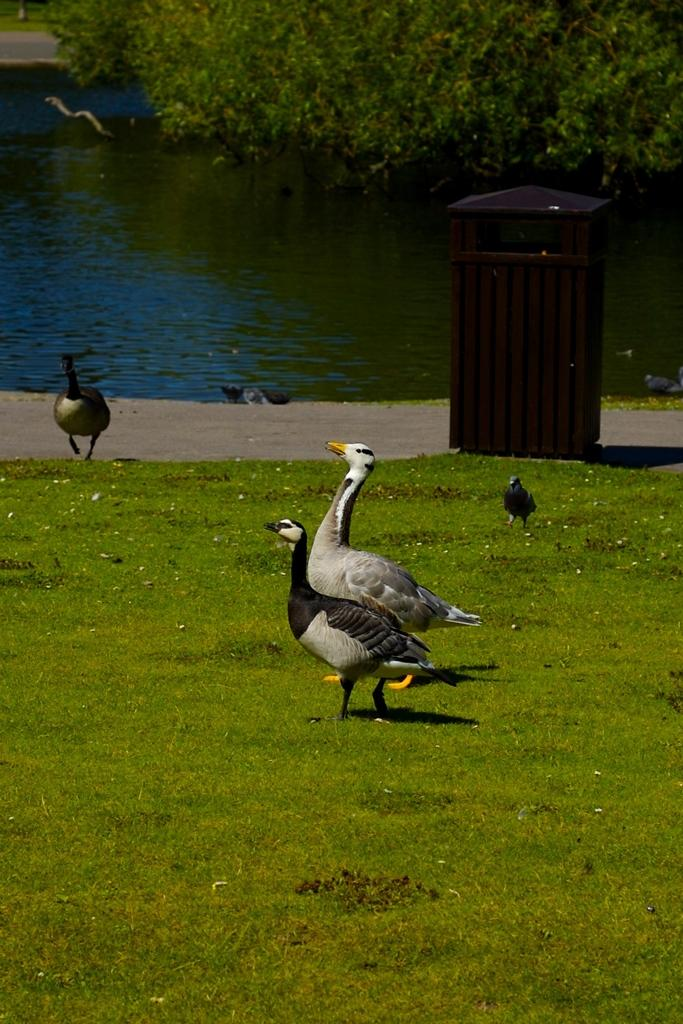What is located in the center of the image? There are birds on the grass in the center of the image. Can you describe the birds in the background? There are birds visible in the background. What objects can be seen in the background of the image? A dustbin, a road, water, and trees are visible in the background. What type of hole can be seen in the image? There is no hole present in the image. 